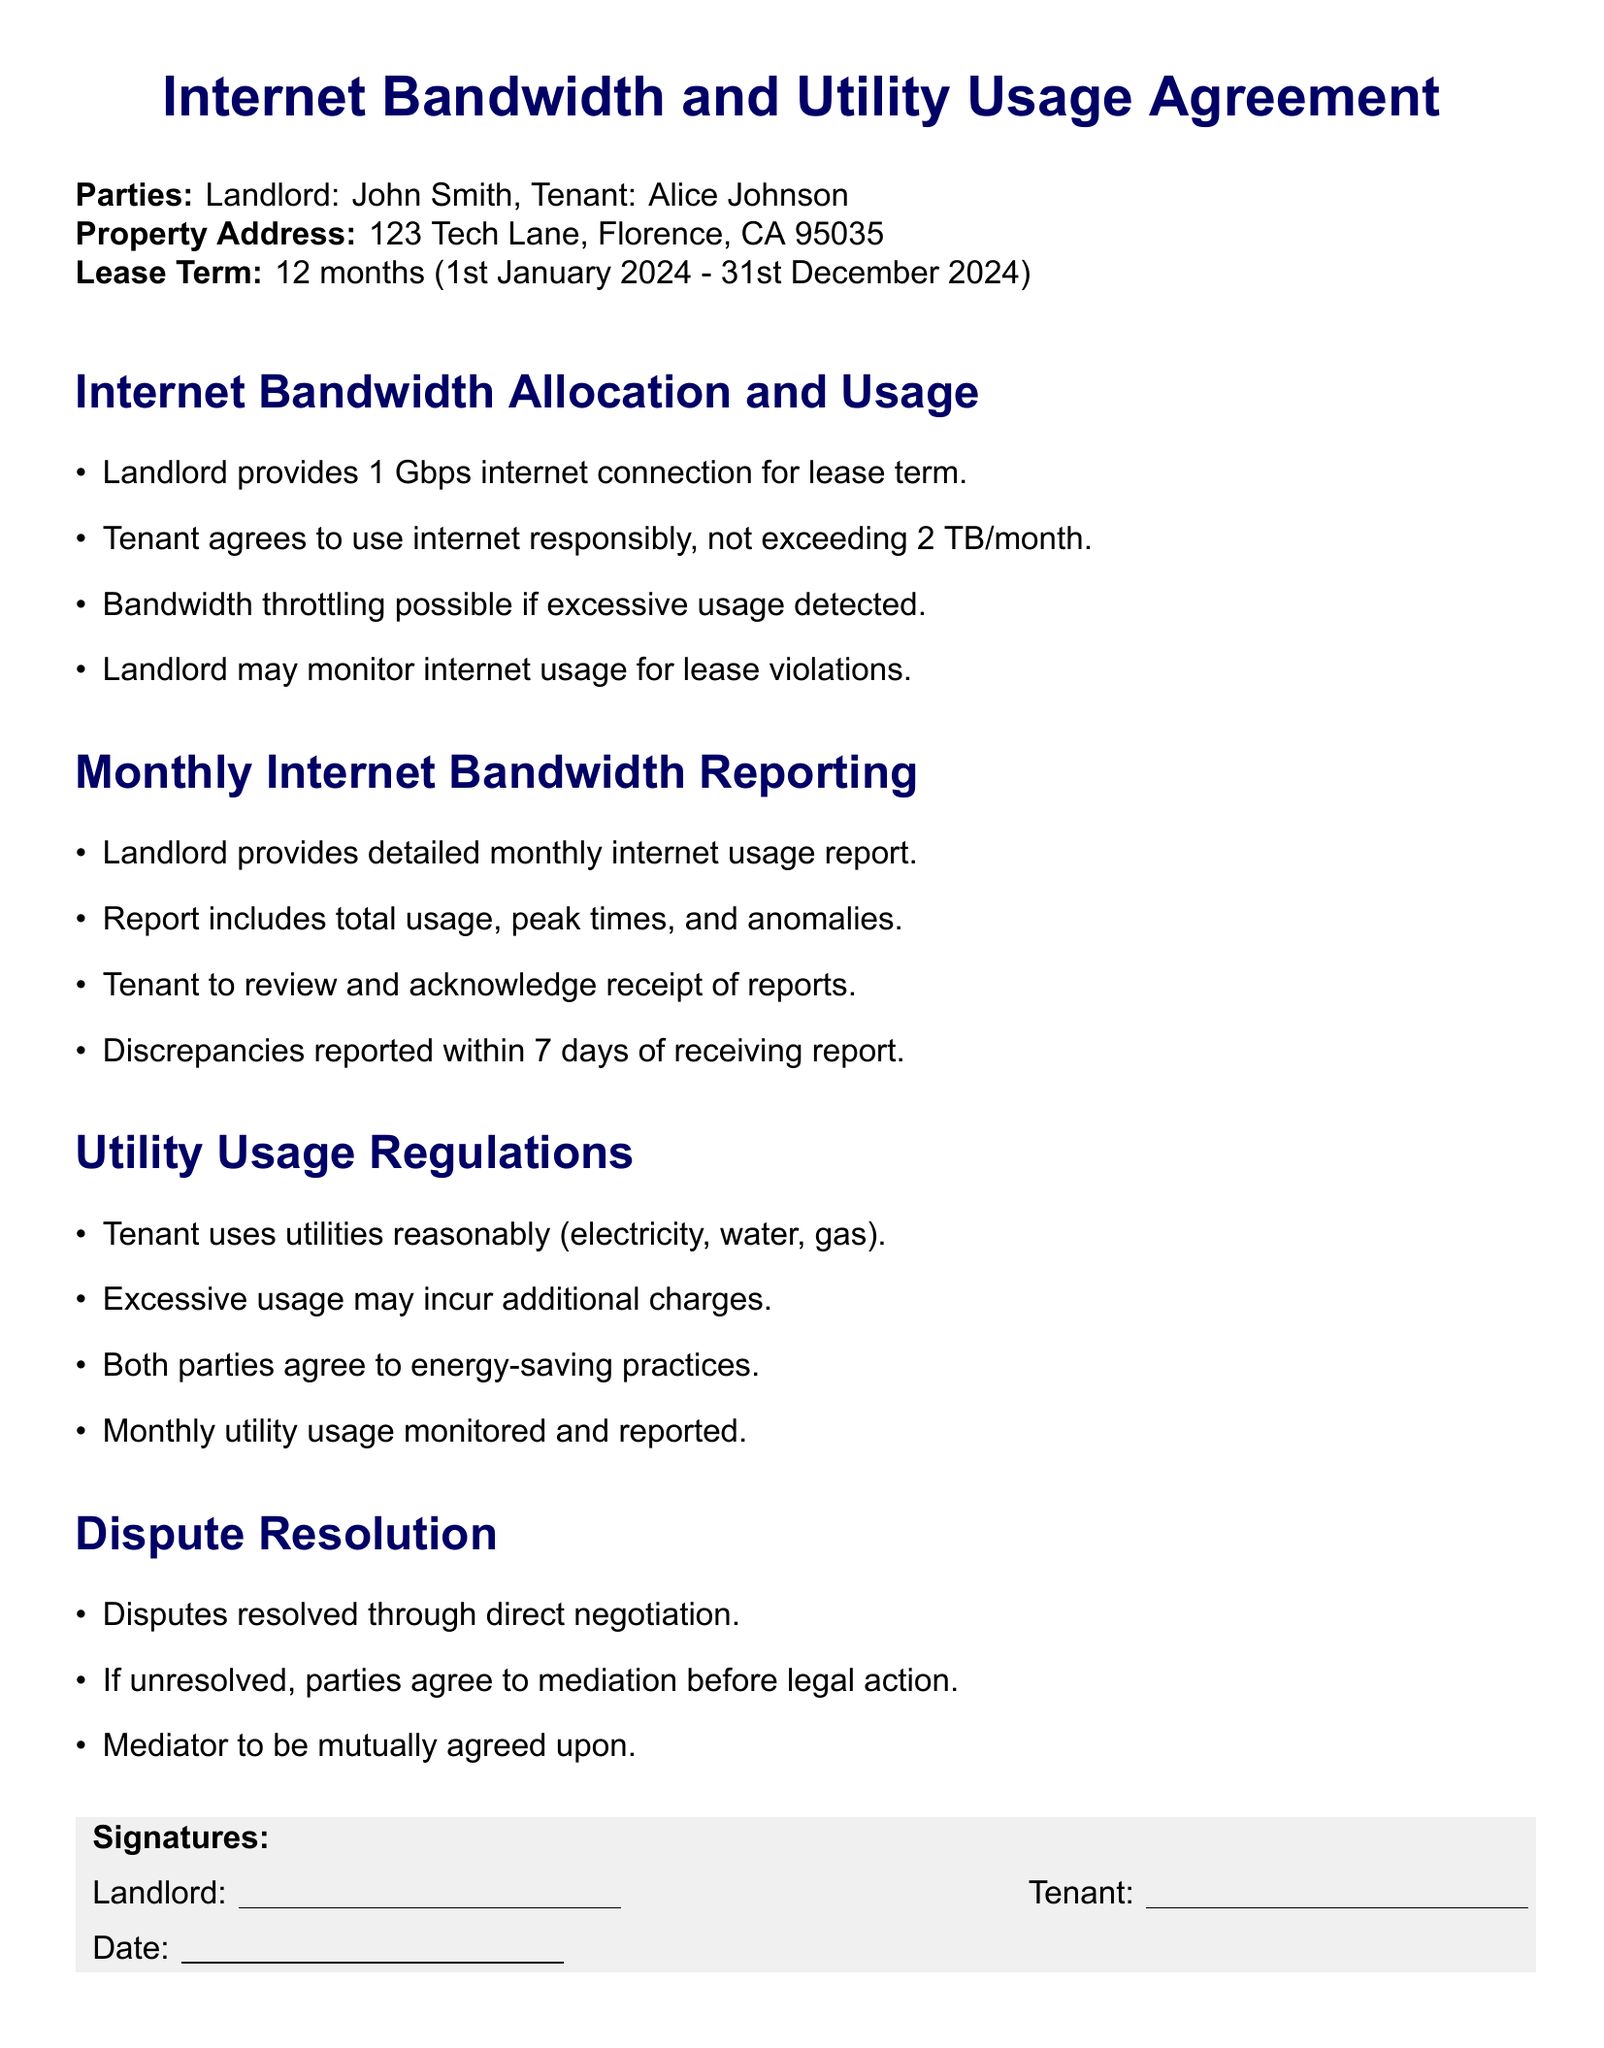What is the name of the landlord? The name of the landlord is listed in the document as "John Smith."
Answer: John Smith What is the lease term duration? The duration of the lease term is specified as 12 months starting from January 1st, 2024, to December 31st, 2024.
Answer: 12 months What is the maximum monthly internet usage allowed? The document states that the tenant agrees not to exceed 2 TB of internet usage per month.
Answer: 2 TB What type of report is provided monthly by the landlord? The report includes total internet usage, peak times, and anomalies, as mentioned in the monthly reporting section.
Answer: Detailed monthly internet usage report What should the tenant do if they find discrepancies in the reports? The tenant is required to report discrepancies within 7 days of receiving the report, as outlined in the document.
Answer: Report within 7 days What utilities must the tenant use reasonably? The document specifies that the tenant must use electricity, water, and gas reasonably.
Answer: Electricity, water, gas What may occur if excessive utility usage is detected? The lease agreement states that excessive utility usage may incur additional charges.
Answer: Additional charges How will disputes be resolved if direct negotiation fails? If direct negotiation is unsuccessful, the agreement states that parties will resort to mediation before legal action.
Answer: Mediation Who acknowledges the receipt of internet usage reports? The tenant is responsible for reviewing and acknowledging receipt of the internet usage reports.
Answer: Tenant 